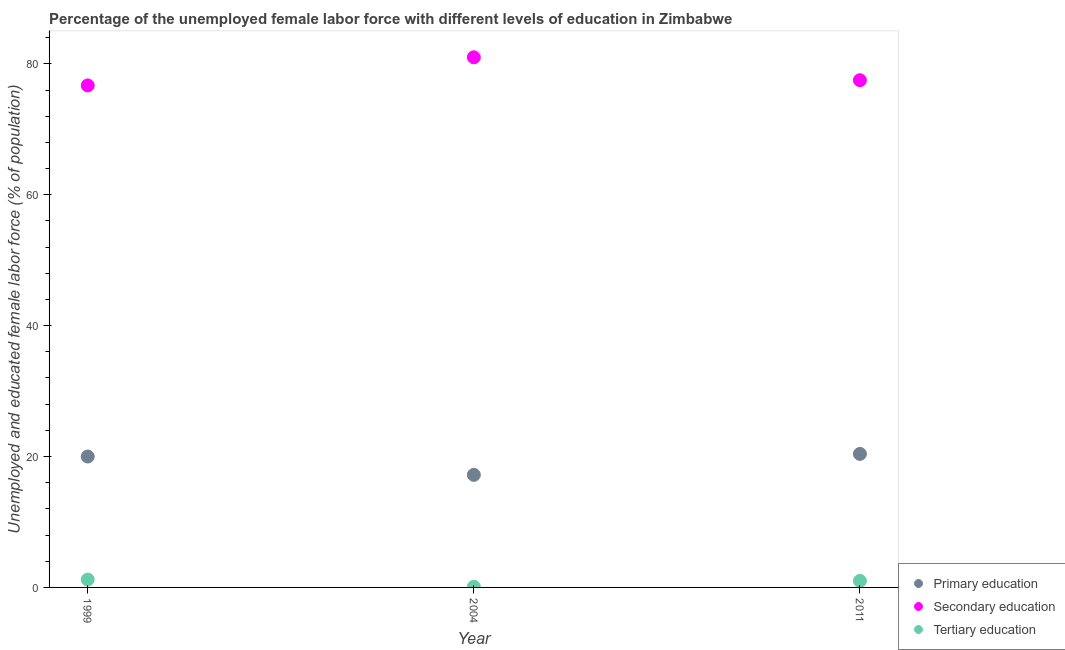How many different coloured dotlines are there?
Your answer should be very brief. 3. Is the number of dotlines equal to the number of legend labels?
Make the answer very short. Yes. What is the percentage of female labor force who received primary education in 2011?
Give a very brief answer. 20.4. Across all years, what is the maximum percentage of female labor force who received primary education?
Ensure brevity in your answer.  20.4. Across all years, what is the minimum percentage of female labor force who received tertiary education?
Ensure brevity in your answer.  0.1. In which year was the percentage of female labor force who received secondary education maximum?
Your response must be concise. 2004. In which year was the percentage of female labor force who received secondary education minimum?
Ensure brevity in your answer.  1999. What is the total percentage of female labor force who received tertiary education in the graph?
Your response must be concise. 2.3. What is the difference between the percentage of female labor force who received tertiary education in 1999 and that in 2011?
Your answer should be compact. 0.2. What is the difference between the percentage of female labor force who received primary education in 1999 and the percentage of female labor force who received tertiary education in 2004?
Your response must be concise. 19.9. What is the average percentage of female labor force who received secondary education per year?
Your response must be concise. 78.4. In the year 2004, what is the difference between the percentage of female labor force who received secondary education and percentage of female labor force who received tertiary education?
Your answer should be compact. 80.9. In how many years, is the percentage of female labor force who received tertiary education greater than 52 %?
Provide a succinct answer. 0. What is the ratio of the percentage of female labor force who received primary education in 1999 to that in 2011?
Provide a short and direct response. 0.98. Is the percentage of female labor force who received tertiary education in 1999 less than that in 2011?
Your response must be concise. No. What is the difference between the highest and the second highest percentage of female labor force who received primary education?
Your answer should be compact. 0.4. What is the difference between the highest and the lowest percentage of female labor force who received primary education?
Keep it short and to the point. 3.2. In how many years, is the percentage of female labor force who received secondary education greater than the average percentage of female labor force who received secondary education taken over all years?
Your response must be concise. 1. Is the sum of the percentage of female labor force who received tertiary education in 2004 and 2011 greater than the maximum percentage of female labor force who received primary education across all years?
Keep it short and to the point. No. Is it the case that in every year, the sum of the percentage of female labor force who received primary education and percentage of female labor force who received secondary education is greater than the percentage of female labor force who received tertiary education?
Your response must be concise. Yes. Is the percentage of female labor force who received tertiary education strictly less than the percentage of female labor force who received secondary education over the years?
Your response must be concise. Yes. How many dotlines are there?
Your response must be concise. 3. What is the difference between two consecutive major ticks on the Y-axis?
Your answer should be compact. 20. Does the graph contain any zero values?
Make the answer very short. No. Does the graph contain grids?
Your answer should be very brief. No. Where does the legend appear in the graph?
Provide a succinct answer. Bottom right. How are the legend labels stacked?
Your response must be concise. Vertical. What is the title of the graph?
Your answer should be very brief. Percentage of the unemployed female labor force with different levels of education in Zimbabwe. What is the label or title of the X-axis?
Your response must be concise. Year. What is the label or title of the Y-axis?
Keep it short and to the point. Unemployed and educated female labor force (% of population). What is the Unemployed and educated female labor force (% of population) in Primary education in 1999?
Make the answer very short. 20. What is the Unemployed and educated female labor force (% of population) in Secondary education in 1999?
Offer a terse response. 76.7. What is the Unemployed and educated female labor force (% of population) of Tertiary education in 1999?
Your response must be concise. 1.2. What is the Unemployed and educated female labor force (% of population) in Primary education in 2004?
Provide a short and direct response. 17.2. What is the Unemployed and educated female labor force (% of population) in Tertiary education in 2004?
Your answer should be compact. 0.1. What is the Unemployed and educated female labor force (% of population) of Primary education in 2011?
Offer a very short reply. 20.4. What is the Unemployed and educated female labor force (% of population) in Secondary education in 2011?
Ensure brevity in your answer.  77.5. Across all years, what is the maximum Unemployed and educated female labor force (% of population) in Primary education?
Offer a terse response. 20.4. Across all years, what is the maximum Unemployed and educated female labor force (% of population) of Secondary education?
Your answer should be compact. 81. Across all years, what is the maximum Unemployed and educated female labor force (% of population) in Tertiary education?
Make the answer very short. 1.2. Across all years, what is the minimum Unemployed and educated female labor force (% of population) of Primary education?
Keep it short and to the point. 17.2. Across all years, what is the minimum Unemployed and educated female labor force (% of population) of Secondary education?
Offer a very short reply. 76.7. Across all years, what is the minimum Unemployed and educated female labor force (% of population) in Tertiary education?
Your response must be concise. 0.1. What is the total Unemployed and educated female labor force (% of population) in Primary education in the graph?
Offer a terse response. 57.6. What is the total Unemployed and educated female labor force (% of population) in Secondary education in the graph?
Provide a succinct answer. 235.2. What is the difference between the Unemployed and educated female labor force (% of population) of Primary education in 1999 and that in 2004?
Provide a short and direct response. 2.8. What is the difference between the Unemployed and educated female labor force (% of population) of Secondary education in 1999 and that in 2004?
Ensure brevity in your answer.  -4.3. What is the difference between the Unemployed and educated female labor force (% of population) of Tertiary education in 1999 and that in 2004?
Ensure brevity in your answer.  1.1. What is the difference between the Unemployed and educated female labor force (% of population) of Primary education in 1999 and that in 2011?
Ensure brevity in your answer.  -0.4. What is the difference between the Unemployed and educated female labor force (% of population) in Primary education in 2004 and that in 2011?
Your answer should be compact. -3.2. What is the difference between the Unemployed and educated female labor force (% of population) of Primary education in 1999 and the Unemployed and educated female labor force (% of population) of Secondary education in 2004?
Give a very brief answer. -61. What is the difference between the Unemployed and educated female labor force (% of population) in Secondary education in 1999 and the Unemployed and educated female labor force (% of population) in Tertiary education in 2004?
Your response must be concise. 76.6. What is the difference between the Unemployed and educated female labor force (% of population) in Primary education in 1999 and the Unemployed and educated female labor force (% of population) in Secondary education in 2011?
Offer a terse response. -57.5. What is the difference between the Unemployed and educated female labor force (% of population) of Secondary education in 1999 and the Unemployed and educated female labor force (% of population) of Tertiary education in 2011?
Your answer should be very brief. 75.7. What is the difference between the Unemployed and educated female labor force (% of population) of Primary education in 2004 and the Unemployed and educated female labor force (% of population) of Secondary education in 2011?
Provide a succinct answer. -60.3. What is the difference between the Unemployed and educated female labor force (% of population) in Primary education in 2004 and the Unemployed and educated female labor force (% of population) in Tertiary education in 2011?
Keep it short and to the point. 16.2. What is the average Unemployed and educated female labor force (% of population) of Secondary education per year?
Give a very brief answer. 78.4. What is the average Unemployed and educated female labor force (% of population) in Tertiary education per year?
Your answer should be compact. 0.77. In the year 1999, what is the difference between the Unemployed and educated female labor force (% of population) in Primary education and Unemployed and educated female labor force (% of population) in Secondary education?
Your response must be concise. -56.7. In the year 1999, what is the difference between the Unemployed and educated female labor force (% of population) in Secondary education and Unemployed and educated female labor force (% of population) in Tertiary education?
Your answer should be compact. 75.5. In the year 2004, what is the difference between the Unemployed and educated female labor force (% of population) in Primary education and Unemployed and educated female labor force (% of population) in Secondary education?
Provide a succinct answer. -63.8. In the year 2004, what is the difference between the Unemployed and educated female labor force (% of population) in Secondary education and Unemployed and educated female labor force (% of population) in Tertiary education?
Provide a short and direct response. 80.9. In the year 2011, what is the difference between the Unemployed and educated female labor force (% of population) in Primary education and Unemployed and educated female labor force (% of population) in Secondary education?
Keep it short and to the point. -57.1. In the year 2011, what is the difference between the Unemployed and educated female labor force (% of population) in Secondary education and Unemployed and educated female labor force (% of population) in Tertiary education?
Your response must be concise. 76.5. What is the ratio of the Unemployed and educated female labor force (% of population) of Primary education in 1999 to that in 2004?
Provide a short and direct response. 1.16. What is the ratio of the Unemployed and educated female labor force (% of population) in Secondary education in 1999 to that in 2004?
Keep it short and to the point. 0.95. What is the ratio of the Unemployed and educated female labor force (% of population) of Primary education in 1999 to that in 2011?
Provide a succinct answer. 0.98. What is the ratio of the Unemployed and educated female labor force (% of population) of Tertiary education in 1999 to that in 2011?
Keep it short and to the point. 1.2. What is the ratio of the Unemployed and educated female labor force (% of population) of Primary education in 2004 to that in 2011?
Provide a short and direct response. 0.84. What is the ratio of the Unemployed and educated female labor force (% of population) in Secondary education in 2004 to that in 2011?
Offer a very short reply. 1.05. What is the ratio of the Unemployed and educated female labor force (% of population) in Tertiary education in 2004 to that in 2011?
Ensure brevity in your answer.  0.1. What is the difference between the highest and the second highest Unemployed and educated female labor force (% of population) of Primary education?
Ensure brevity in your answer.  0.4. What is the difference between the highest and the second highest Unemployed and educated female labor force (% of population) in Secondary education?
Your answer should be very brief. 3.5. What is the difference between the highest and the lowest Unemployed and educated female labor force (% of population) in Secondary education?
Offer a very short reply. 4.3. 